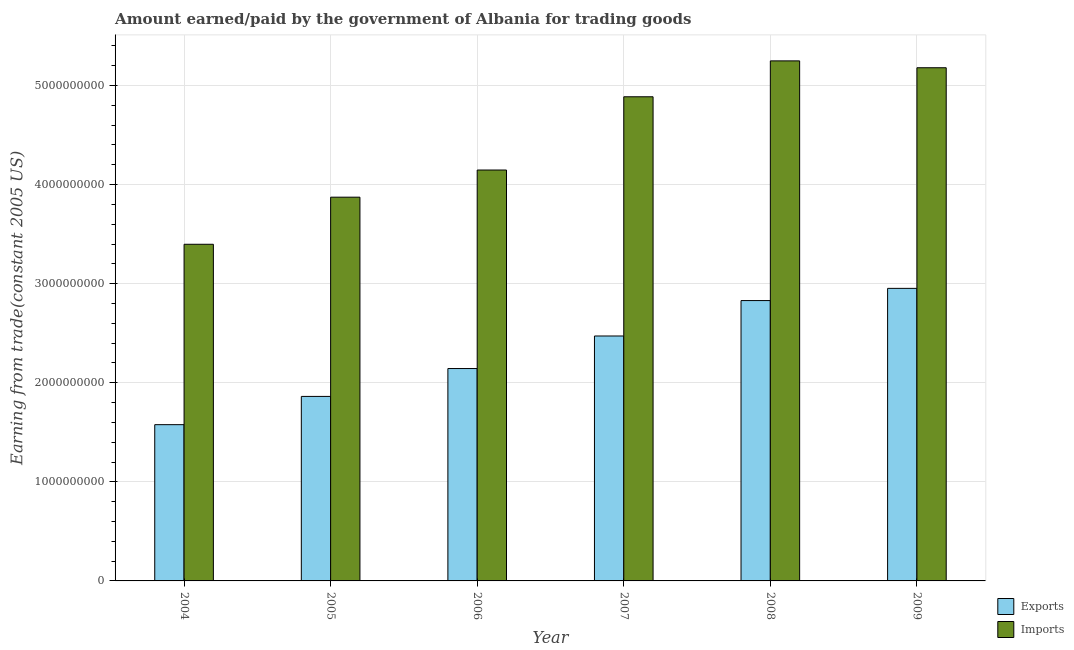How many different coloured bars are there?
Offer a very short reply. 2. How many groups of bars are there?
Keep it short and to the point. 6. Are the number of bars per tick equal to the number of legend labels?
Your response must be concise. Yes. Are the number of bars on each tick of the X-axis equal?
Keep it short and to the point. Yes. How many bars are there on the 3rd tick from the left?
Offer a terse response. 2. What is the label of the 1st group of bars from the left?
Provide a short and direct response. 2004. What is the amount paid for imports in 2009?
Offer a terse response. 5.18e+09. Across all years, what is the maximum amount earned from exports?
Make the answer very short. 2.95e+09. Across all years, what is the minimum amount paid for imports?
Make the answer very short. 3.40e+09. In which year was the amount earned from exports maximum?
Provide a succinct answer. 2009. What is the total amount paid for imports in the graph?
Offer a terse response. 2.67e+1. What is the difference between the amount earned from exports in 2005 and that in 2006?
Your answer should be compact. -2.81e+08. What is the difference between the amount paid for imports in 2005 and the amount earned from exports in 2006?
Make the answer very short. -2.74e+08. What is the average amount paid for imports per year?
Ensure brevity in your answer.  4.46e+09. What is the ratio of the amount paid for imports in 2004 to that in 2009?
Your response must be concise. 0.66. What is the difference between the highest and the second highest amount paid for imports?
Your answer should be very brief. 6.93e+07. What is the difference between the highest and the lowest amount earned from exports?
Keep it short and to the point. 1.38e+09. What does the 1st bar from the left in 2007 represents?
Your response must be concise. Exports. What does the 1st bar from the right in 2006 represents?
Your answer should be very brief. Imports. How many bars are there?
Ensure brevity in your answer.  12. How many years are there in the graph?
Offer a very short reply. 6. What is the difference between two consecutive major ticks on the Y-axis?
Your response must be concise. 1.00e+09. Are the values on the major ticks of Y-axis written in scientific E-notation?
Your answer should be very brief. No. Does the graph contain grids?
Offer a very short reply. Yes. How many legend labels are there?
Your answer should be compact. 2. How are the legend labels stacked?
Make the answer very short. Vertical. What is the title of the graph?
Keep it short and to the point. Amount earned/paid by the government of Albania for trading goods. What is the label or title of the Y-axis?
Keep it short and to the point. Earning from trade(constant 2005 US). What is the Earning from trade(constant 2005 US) of Exports in 2004?
Ensure brevity in your answer.  1.58e+09. What is the Earning from trade(constant 2005 US) in Imports in 2004?
Offer a very short reply. 3.40e+09. What is the Earning from trade(constant 2005 US) of Exports in 2005?
Your answer should be compact. 1.86e+09. What is the Earning from trade(constant 2005 US) in Imports in 2005?
Keep it short and to the point. 3.87e+09. What is the Earning from trade(constant 2005 US) in Exports in 2006?
Make the answer very short. 2.14e+09. What is the Earning from trade(constant 2005 US) of Imports in 2006?
Provide a short and direct response. 4.15e+09. What is the Earning from trade(constant 2005 US) in Exports in 2007?
Your response must be concise. 2.47e+09. What is the Earning from trade(constant 2005 US) in Imports in 2007?
Provide a succinct answer. 4.89e+09. What is the Earning from trade(constant 2005 US) in Exports in 2008?
Make the answer very short. 2.83e+09. What is the Earning from trade(constant 2005 US) of Imports in 2008?
Your answer should be compact. 5.25e+09. What is the Earning from trade(constant 2005 US) in Exports in 2009?
Your answer should be compact. 2.95e+09. What is the Earning from trade(constant 2005 US) in Imports in 2009?
Keep it short and to the point. 5.18e+09. Across all years, what is the maximum Earning from trade(constant 2005 US) of Exports?
Offer a terse response. 2.95e+09. Across all years, what is the maximum Earning from trade(constant 2005 US) of Imports?
Keep it short and to the point. 5.25e+09. Across all years, what is the minimum Earning from trade(constant 2005 US) of Exports?
Make the answer very short. 1.58e+09. Across all years, what is the minimum Earning from trade(constant 2005 US) of Imports?
Give a very brief answer. 3.40e+09. What is the total Earning from trade(constant 2005 US) of Exports in the graph?
Provide a succinct answer. 1.38e+1. What is the total Earning from trade(constant 2005 US) in Imports in the graph?
Your response must be concise. 2.67e+1. What is the difference between the Earning from trade(constant 2005 US) in Exports in 2004 and that in 2005?
Make the answer very short. -2.85e+08. What is the difference between the Earning from trade(constant 2005 US) in Imports in 2004 and that in 2005?
Offer a very short reply. -4.75e+08. What is the difference between the Earning from trade(constant 2005 US) in Exports in 2004 and that in 2006?
Your answer should be very brief. -5.66e+08. What is the difference between the Earning from trade(constant 2005 US) in Imports in 2004 and that in 2006?
Offer a terse response. -7.49e+08. What is the difference between the Earning from trade(constant 2005 US) of Exports in 2004 and that in 2007?
Provide a succinct answer. -8.95e+08. What is the difference between the Earning from trade(constant 2005 US) in Imports in 2004 and that in 2007?
Give a very brief answer. -1.49e+09. What is the difference between the Earning from trade(constant 2005 US) of Exports in 2004 and that in 2008?
Your response must be concise. -1.25e+09. What is the difference between the Earning from trade(constant 2005 US) of Imports in 2004 and that in 2008?
Your answer should be very brief. -1.85e+09. What is the difference between the Earning from trade(constant 2005 US) in Exports in 2004 and that in 2009?
Offer a very short reply. -1.38e+09. What is the difference between the Earning from trade(constant 2005 US) in Imports in 2004 and that in 2009?
Give a very brief answer. -1.78e+09. What is the difference between the Earning from trade(constant 2005 US) in Exports in 2005 and that in 2006?
Offer a very short reply. -2.81e+08. What is the difference between the Earning from trade(constant 2005 US) of Imports in 2005 and that in 2006?
Give a very brief answer. -2.74e+08. What is the difference between the Earning from trade(constant 2005 US) in Exports in 2005 and that in 2007?
Make the answer very short. -6.10e+08. What is the difference between the Earning from trade(constant 2005 US) of Imports in 2005 and that in 2007?
Provide a short and direct response. -1.01e+09. What is the difference between the Earning from trade(constant 2005 US) in Exports in 2005 and that in 2008?
Your answer should be very brief. -9.67e+08. What is the difference between the Earning from trade(constant 2005 US) in Imports in 2005 and that in 2008?
Keep it short and to the point. -1.38e+09. What is the difference between the Earning from trade(constant 2005 US) in Exports in 2005 and that in 2009?
Provide a succinct answer. -1.09e+09. What is the difference between the Earning from trade(constant 2005 US) of Imports in 2005 and that in 2009?
Offer a terse response. -1.31e+09. What is the difference between the Earning from trade(constant 2005 US) of Exports in 2006 and that in 2007?
Your answer should be compact. -3.28e+08. What is the difference between the Earning from trade(constant 2005 US) in Imports in 2006 and that in 2007?
Your answer should be compact. -7.39e+08. What is the difference between the Earning from trade(constant 2005 US) in Exports in 2006 and that in 2008?
Your answer should be very brief. -6.86e+08. What is the difference between the Earning from trade(constant 2005 US) of Imports in 2006 and that in 2008?
Your response must be concise. -1.10e+09. What is the difference between the Earning from trade(constant 2005 US) of Exports in 2006 and that in 2009?
Make the answer very short. -8.09e+08. What is the difference between the Earning from trade(constant 2005 US) of Imports in 2006 and that in 2009?
Make the answer very short. -1.03e+09. What is the difference between the Earning from trade(constant 2005 US) in Exports in 2007 and that in 2008?
Your answer should be compact. -3.57e+08. What is the difference between the Earning from trade(constant 2005 US) of Imports in 2007 and that in 2008?
Provide a short and direct response. -3.62e+08. What is the difference between the Earning from trade(constant 2005 US) of Exports in 2007 and that in 2009?
Your answer should be compact. -4.81e+08. What is the difference between the Earning from trade(constant 2005 US) in Imports in 2007 and that in 2009?
Provide a short and direct response. -2.93e+08. What is the difference between the Earning from trade(constant 2005 US) of Exports in 2008 and that in 2009?
Keep it short and to the point. -1.23e+08. What is the difference between the Earning from trade(constant 2005 US) of Imports in 2008 and that in 2009?
Make the answer very short. 6.93e+07. What is the difference between the Earning from trade(constant 2005 US) in Exports in 2004 and the Earning from trade(constant 2005 US) in Imports in 2005?
Provide a short and direct response. -2.30e+09. What is the difference between the Earning from trade(constant 2005 US) of Exports in 2004 and the Earning from trade(constant 2005 US) of Imports in 2006?
Your answer should be very brief. -2.57e+09. What is the difference between the Earning from trade(constant 2005 US) of Exports in 2004 and the Earning from trade(constant 2005 US) of Imports in 2007?
Ensure brevity in your answer.  -3.31e+09. What is the difference between the Earning from trade(constant 2005 US) of Exports in 2004 and the Earning from trade(constant 2005 US) of Imports in 2008?
Make the answer very short. -3.67e+09. What is the difference between the Earning from trade(constant 2005 US) in Exports in 2004 and the Earning from trade(constant 2005 US) in Imports in 2009?
Offer a very short reply. -3.60e+09. What is the difference between the Earning from trade(constant 2005 US) of Exports in 2005 and the Earning from trade(constant 2005 US) of Imports in 2006?
Give a very brief answer. -2.28e+09. What is the difference between the Earning from trade(constant 2005 US) of Exports in 2005 and the Earning from trade(constant 2005 US) of Imports in 2007?
Ensure brevity in your answer.  -3.02e+09. What is the difference between the Earning from trade(constant 2005 US) in Exports in 2005 and the Earning from trade(constant 2005 US) in Imports in 2008?
Ensure brevity in your answer.  -3.39e+09. What is the difference between the Earning from trade(constant 2005 US) of Exports in 2005 and the Earning from trade(constant 2005 US) of Imports in 2009?
Give a very brief answer. -3.32e+09. What is the difference between the Earning from trade(constant 2005 US) of Exports in 2006 and the Earning from trade(constant 2005 US) of Imports in 2007?
Your response must be concise. -2.74e+09. What is the difference between the Earning from trade(constant 2005 US) in Exports in 2006 and the Earning from trade(constant 2005 US) in Imports in 2008?
Provide a succinct answer. -3.11e+09. What is the difference between the Earning from trade(constant 2005 US) of Exports in 2006 and the Earning from trade(constant 2005 US) of Imports in 2009?
Provide a succinct answer. -3.04e+09. What is the difference between the Earning from trade(constant 2005 US) in Exports in 2007 and the Earning from trade(constant 2005 US) in Imports in 2008?
Ensure brevity in your answer.  -2.78e+09. What is the difference between the Earning from trade(constant 2005 US) of Exports in 2007 and the Earning from trade(constant 2005 US) of Imports in 2009?
Offer a terse response. -2.71e+09. What is the difference between the Earning from trade(constant 2005 US) in Exports in 2008 and the Earning from trade(constant 2005 US) in Imports in 2009?
Provide a succinct answer. -2.35e+09. What is the average Earning from trade(constant 2005 US) in Exports per year?
Keep it short and to the point. 2.31e+09. What is the average Earning from trade(constant 2005 US) in Imports per year?
Make the answer very short. 4.46e+09. In the year 2004, what is the difference between the Earning from trade(constant 2005 US) in Exports and Earning from trade(constant 2005 US) in Imports?
Your response must be concise. -1.82e+09. In the year 2005, what is the difference between the Earning from trade(constant 2005 US) of Exports and Earning from trade(constant 2005 US) of Imports?
Provide a short and direct response. -2.01e+09. In the year 2006, what is the difference between the Earning from trade(constant 2005 US) in Exports and Earning from trade(constant 2005 US) in Imports?
Your answer should be compact. -2.00e+09. In the year 2007, what is the difference between the Earning from trade(constant 2005 US) in Exports and Earning from trade(constant 2005 US) in Imports?
Provide a short and direct response. -2.41e+09. In the year 2008, what is the difference between the Earning from trade(constant 2005 US) of Exports and Earning from trade(constant 2005 US) of Imports?
Your answer should be compact. -2.42e+09. In the year 2009, what is the difference between the Earning from trade(constant 2005 US) of Exports and Earning from trade(constant 2005 US) of Imports?
Provide a succinct answer. -2.23e+09. What is the ratio of the Earning from trade(constant 2005 US) in Exports in 2004 to that in 2005?
Give a very brief answer. 0.85. What is the ratio of the Earning from trade(constant 2005 US) of Imports in 2004 to that in 2005?
Offer a terse response. 0.88. What is the ratio of the Earning from trade(constant 2005 US) in Exports in 2004 to that in 2006?
Your answer should be very brief. 0.74. What is the ratio of the Earning from trade(constant 2005 US) in Imports in 2004 to that in 2006?
Your answer should be compact. 0.82. What is the ratio of the Earning from trade(constant 2005 US) of Exports in 2004 to that in 2007?
Give a very brief answer. 0.64. What is the ratio of the Earning from trade(constant 2005 US) of Imports in 2004 to that in 2007?
Keep it short and to the point. 0.7. What is the ratio of the Earning from trade(constant 2005 US) of Exports in 2004 to that in 2008?
Your answer should be compact. 0.56. What is the ratio of the Earning from trade(constant 2005 US) in Imports in 2004 to that in 2008?
Make the answer very short. 0.65. What is the ratio of the Earning from trade(constant 2005 US) of Exports in 2004 to that in 2009?
Offer a terse response. 0.53. What is the ratio of the Earning from trade(constant 2005 US) of Imports in 2004 to that in 2009?
Offer a terse response. 0.66. What is the ratio of the Earning from trade(constant 2005 US) of Exports in 2005 to that in 2006?
Keep it short and to the point. 0.87. What is the ratio of the Earning from trade(constant 2005 US) in Imports in 2005 to that in 2006?
Your response must be concise. 0.93. What is the ratio of the Earning from trade(constant 2005 US) of Exports in 2005 to that in 2007?
Make the answer very short. 0.75. What is the ratio of the Earning from trade(constant 2005 US) of Imports in 2005 to that in 2007?
Give a very brief answer. 0.79. What is the ratio of the Earning from trade(constant 2005 US) of Exports in 2005 to that in 2008?
Offer a terse response. 0.66. What is the ratio of the Earning from trade(constant 2005 US) of Imports in 2005 to that in 2008?
Offer a very short reply. 0.74. What is the ratio of the Earning from trade(constant 2005 US) in Exports in 2005 to that in 2009?
Provide a succinct answer. 0.63. What is the ratio of the Earning from trade(constant 2005 US) in Imports in 2005 to that in 2009?
Provide a succinct answer. 0.75. What is the ratio of the Earning from trade(constant 2005 US) of Exports in 2006 to that in 2007?
Offer a terse response. 0.87. What is the ratio of the Earning from trade(constant 2005 US) in Imports in 2006 to that in 2007?
Offer a terse response. 0.85. What is the ratio of the Earning from trade(constant 2005 US) of Exports in 2006 to that in 2008?
Your answer should be compact. 0.76. What is the ratio of the Earning from trade(constant 2005 US) in Imports in 2006 to that in 2008?
Offer a very short reply. 0.79. What is the ratio of the Earning from trade(constant 2005 US) of Exports in 2006 to that in 2009?
Make the answer very short. 0.73. What is the ratio of the Earning from trade(constant 2005 US) in Imports in 2006 to that in 2009?
Provide a succinct answer. 0.8. What is the ratio of the Earning from trade(constant 2005 US) in Exports in 2007 to that in 2008?
Provide a succinct answer. 0.87. What is the ratio of the Earning from trade(constant 2005 US) of Imports in 2007 to that in 2008?
Give a very brief answer. 0.93. What is the ratio of the Earning from trade(constant 2005 US) in Exports in 2007 to that in 2009?
Keep it short and to the point. 0.84. What is the ratio of the Earning from trade(constant 2005 US) of Imports in 2007 to that in 2009?
Offer a terse response. 0.94. What is the ratio of the Earning from trade(constant 2005 US) in Imports in 2008 to that in 2009?
Provide a succinct answer. 1.01. What is the difference between the highest and the second highest Earning from trade(constant 2005 US) in Exports?
Offer a very short reply. 1.23e+08. What is the difference between the highest and the second highest Earning from trade(constant 2005 US) of Imports?
Your response must be concise. 6.93e+07. What is the difference between the highest and the lowest Earning from trade(constant 2005 US) of Exports?
Your response must be concise. 1.38e+09. What is the difference between the highest and the lowest Earning from trade(constant 2005 US) of Imports?
Your response must be concise. 1.85e+09. 